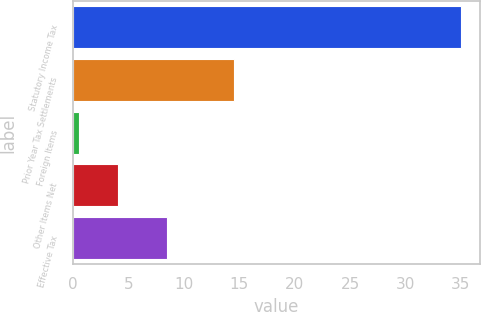<chart> <loc_0><loc_0><loc_500><loc_500><bar_chart><fcel>Statutory Income Tax<fcel>Prior Year Tax Settlements<fcel>Foreign Items<fcel>Other Items Net<fcel>Effective Tax<nl><fcel>35<fcel>14.5<fcel>0.6<fcel>4.04<fcel>8.5<nl></chart> 